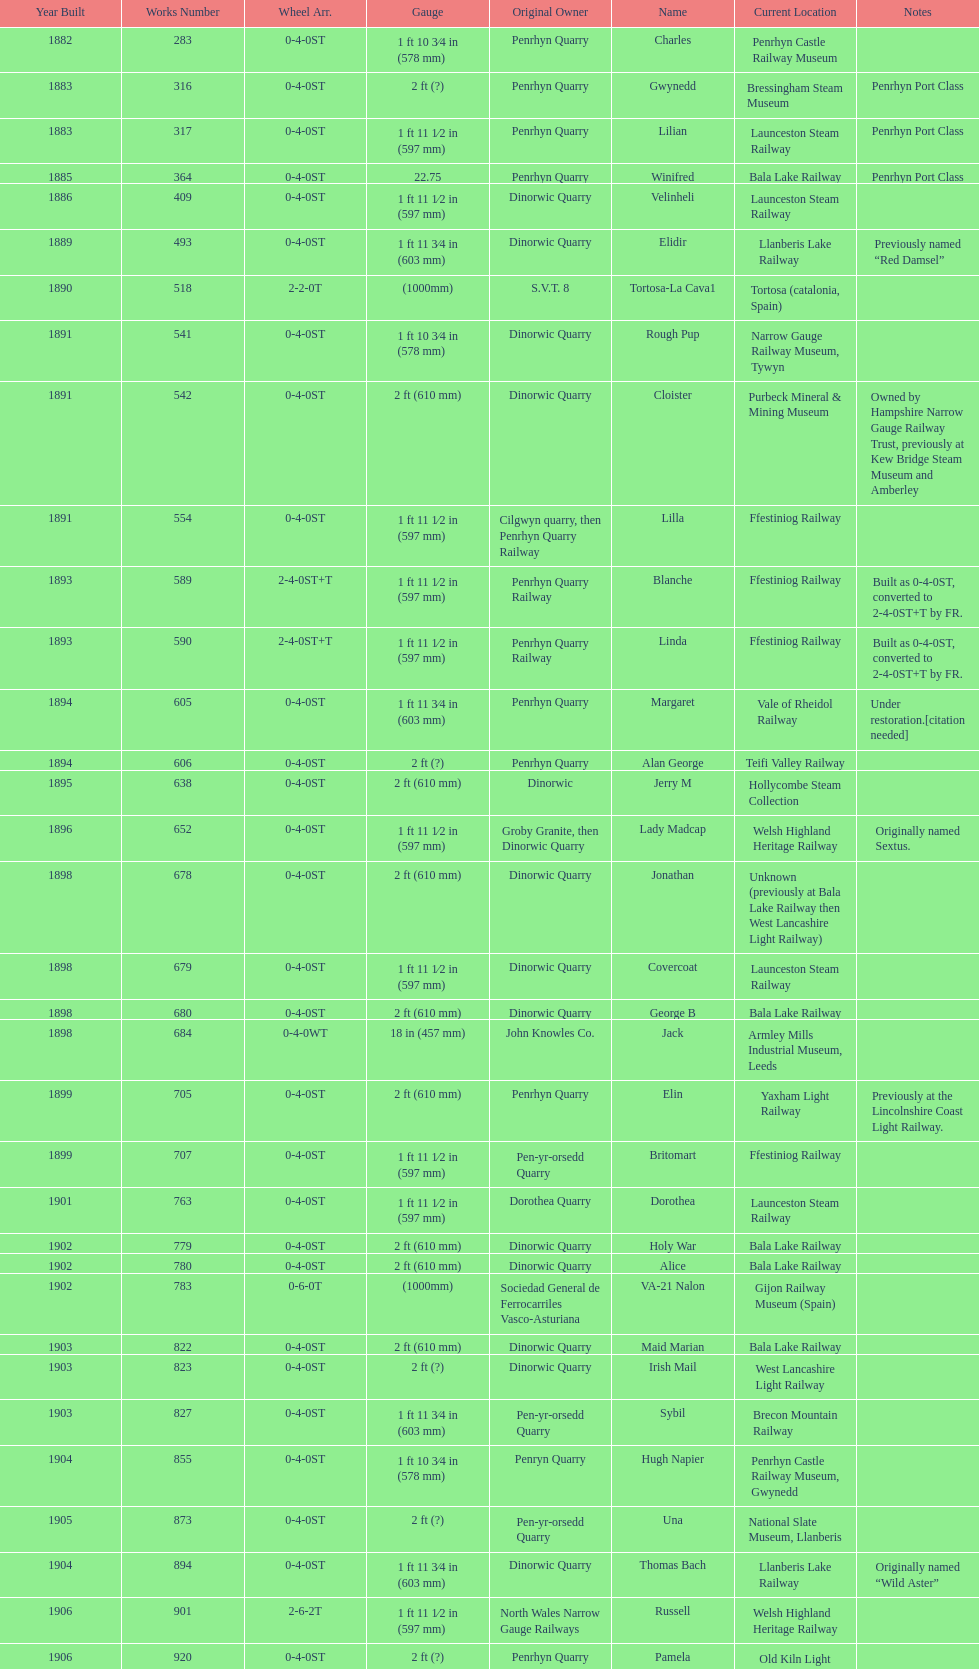After 1940, how many steam locomotives were built? 2. 